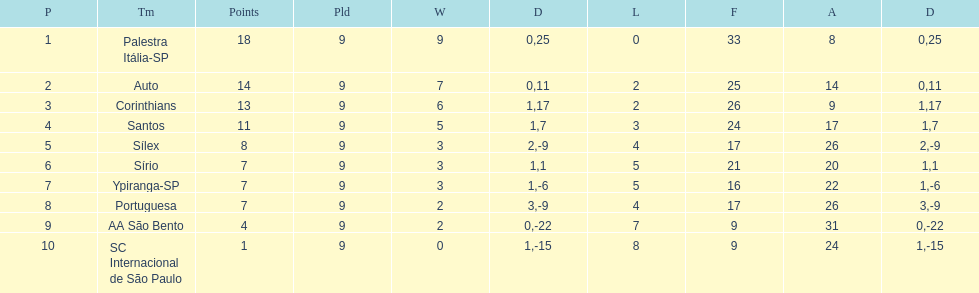Which is the only team to score 13 points in 9 games? Corinthians. Parse the full table. {'header': ['P', 'Tm', 'Points', 'Pld', 'W', 'D', 'L', 'F', 'A', 'D'], 'rows': [['1', 'Palestra Itália-SP', '18', '9', '9', '0', '0', '33', '8', '25'], ['2', 'Auto', '14', '9', '7', '0', '2', '25', '14', '11'], ['3', 'Corinthians', '13', '9', '6', '1', '2', '26', '9', '17'], ['4', 'Santos', '11', '9', '5', '1', '3', '24', '17', '7'], ['5', 'Sílex', '8', '9', '3', '2', '4', '17', '26', '-9'], ['6', 'Sírio', '7', '9', '3', '1', '5', '21', '20', '1'], ['7', 'Ypiranga-SP', '7', '9', '3', '1', '5', '16', '22', '-6'], ['8', 'Portuguesa', '7', '9', '2', '3', '4', '17', '26', '-9'], ['9', 'AA São Bento', '4', '9', '2', '0', '7', '9', '31', '-22'], ['10', 'SC Internacional de São Paulo', '1', '9', '0', '1', '8', '9', '24', '-15']]} 